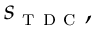Convert formula to latex. <formula><loc_0><loc_0><loc_500><loc_500>s _ { t d c } ,</formula> 